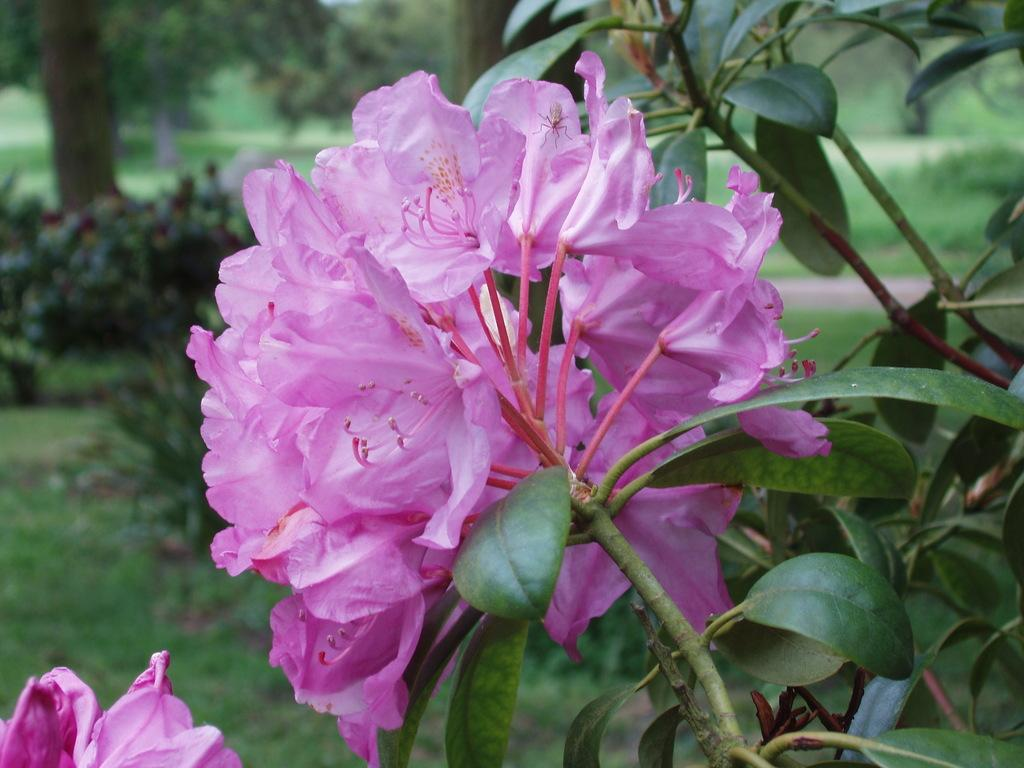What color are the flowers on the plant in the image? The flowers on the plant are pink. What can be seen in the background of the image? There are trees, plants, and grass on the ground in the background of the image. How is the background of the image depicted? The background is blurred. What type of coal is being used to make the apparel in the image? There is no coal or apparel present in the image; it features pink flowers on a plant and a blurred background. 